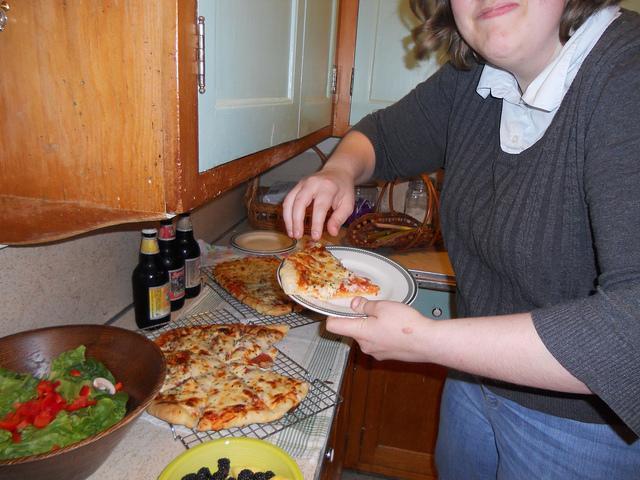What will the woman drink with her pizza?
From the following set of four choices, select the accurate answer to respond to the question.
Options: Milk, coke, beer, wine. Beer. 